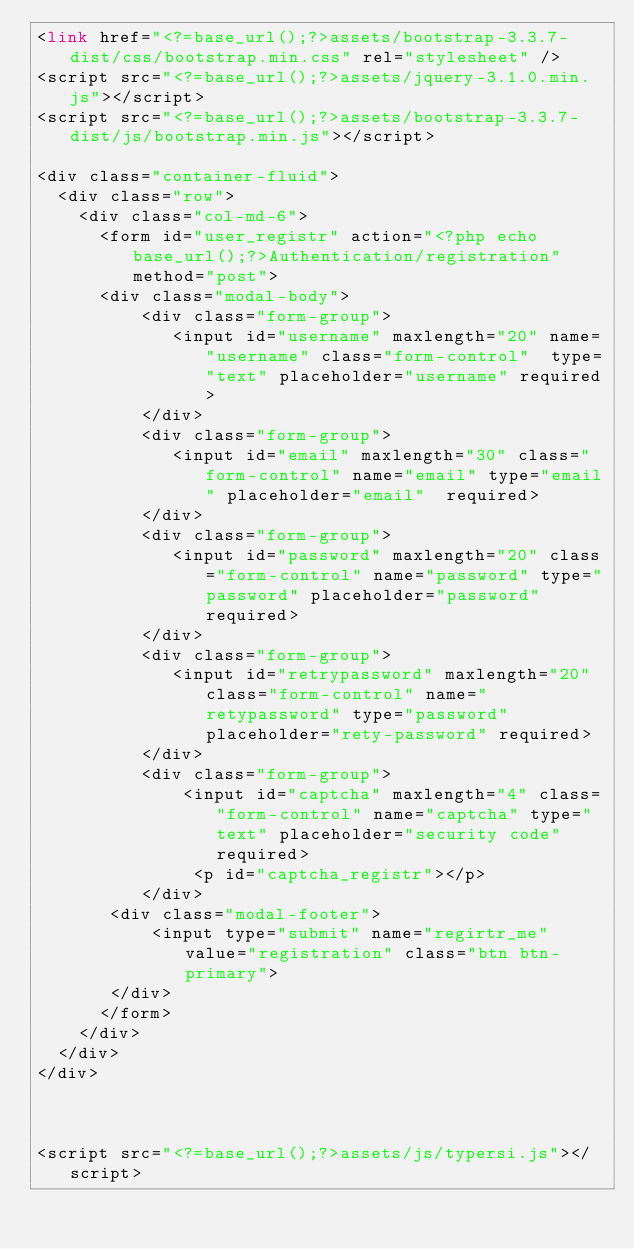Convert code to text. <code><loc_0><loc_0><loc_500><loc_500><_PHP_><link href="<?=base_url();?>assets/bootstrap-3.3.7-dist/css/bootstrap.min.css" rel="stylesheet" />
<script src="<?=base_url();?>assets/jquery-3.1.0.min.js"></script>
<script src="<?=base_url();?>assets/bootstrap-3.3.7-dist/js/bootstrap.min.js"></script>

<div class="container-fluid">
  <div class="row">
    <div class="col-md-6">
      <form id="user_registr" action="<?php echo base_url();?>Authentication/registration" method="post">
      <div class="modal-body">
          <div class="form-group">
             <input id="username" maxlength="20" name="username" class="form-control"  type="text" placeholder="username" required>
          </div>
          <div class="form-group">
             <input id="email" maxlength="30" class="form-control" name="email" type="email" placeholder="email"  required>
          </div>
          <div class="form-group">
             <input id="password" maxlength="20" class="form-control" name="password" type="password" placeholder="password" required>
          </div>
          <div class="form-group">
             <input id="retrypassword" maxlength="20" class="form-control" name="retypassword" type="password" placeholder="rety-password" required>
          </div>
          <div class="form-group">
              <input id="captcha" maxlength="4" class="form-control" name="captcha" type="text" placeholder="security code" required>
               <p id="captcha_registr"></p>
          </div>
       <div class="modal-footer">
           <input type="submit" name="regirtr_me" value="registration" class="btn btn-primary">
       </div>
      </form>
    </div>
  </div>
</div>



<script src="<?=base_url();?>assets/js/typersi.js"></script>
</code> 